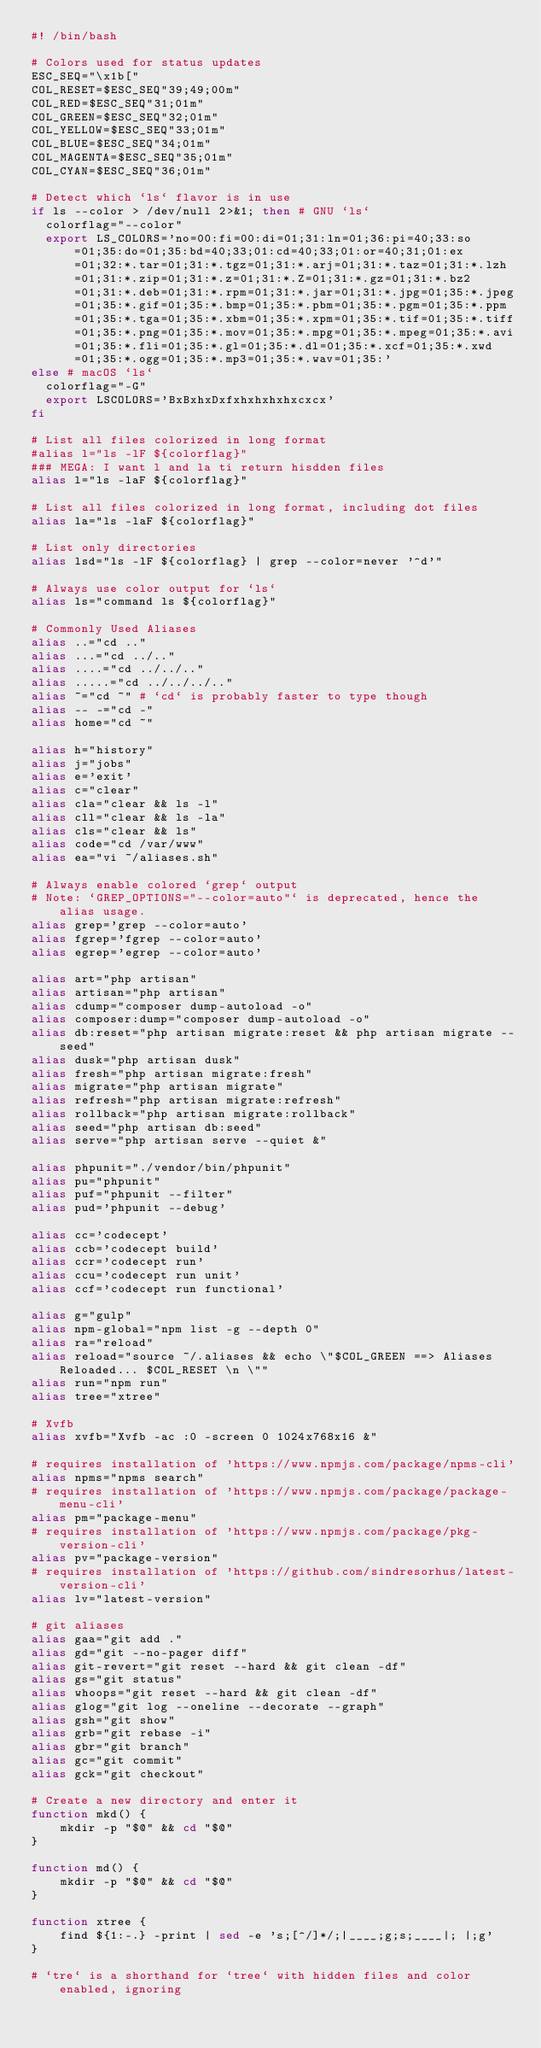<code> <loc_0><loc_0><loc_500><loc_500><_Bash_>#! /bin/bash

# Colors used for status updates
ESC_SEQ="\x1b["
COL_RESET=$ESC_SEQ"39;49;00m"
COL_RED=$ESC_SEQ"31;01m"
COL_GREEN=$ESC_SEQ"32;01m"
COL_YELLOW=$ESC_SEQ"33;01m"
COL_BLUE=$ESC_SEQ"34;01m"
COL_MAGENTA=$ESC_SEQ"35;01m"
COL_CYAN=$ESC_SEQ"36;01m"

# Detect which `ls` flavor is in use
if ls --color > /dev/null 2>&1; then # GNU `ls`
	colorflag="--color"
	export LS_COLORS='no=00:fi=00:di=01;31:ln=01;36:pi=40;33:so=01;35:do=01;35:bd=40;33;01:cd=40;33;01:or=40;31;01:ex=01;32:*.tar=01;31:*.tgz=01;31:*.arj=01;31:*.taz=01;31:*.lzh=01;31:*.zip=01;31:*.z=01;31:*.Z=01;31:*.gz=01;31:*.bz2=01;31:*.deb=01;31:*.rpm=01;31:*.jar=01;31:*.jpg=01;35:*.jpeg=01;35:*.gif=01;35:*.bmp=01;35:*.pbm=01;35:*.pgm=01;35:*.ppm=01;35:*.tga=01;35:*.xbm=01;35:*.xpm=01;35:*.tif=01;35:*.tiff=01;35:*.png=01;35:*.mov=01;35:*.mpg=01;35:*.mpeg=01;35:*.avi=01;35:*.fli=01;35:*.gl=01;35:*.dl=01;35:*.xcf=01;35:*.xwd=01;35:*.ogg=01;35:*.mp3=01;35:*.wav=01;35:'
else # macOS `ls`
	colorflag="-G"
	export LSCOLORS='BxBxhxDxfxhxhxhxhxcxcx'
fi

# List all files colorized in long format
#alias l="ls -lF ${colorflag}"
### MEGA: I want l and la ti return hisdden files
alias l="ls -laF ${colorflag}"

# List all files colorized in long format, including dot files
alias la="ls -laF ${colorflag}"

# List only directories
alias lsd="ls -lF ${colorflag} | grep --color=never '^d'"

# Always use color output for `ls`
alias ls="command ls ${colorflag}"

# Commonly Used Aliases
alias ..="cd .."
alias ...="cd ../.."
alias ....="cd ../../.."
alias .....="cd ../../../.."
alias ~="cd ~" # `cd` is probably faster to type though
alias -- -="cd -"
alias home="cd ~"

alias h="history"
alias j="jobs"
alias e='exit'
alias c="clear"
alias cla="clear && ls -l"
alias cll="clear && ls -la"
alias cls="clear && ls"
alias code="cd /var/www"
alias ea="vi ~/aliases.sh"

# Always enable colored `grep` output
# Note: `GREP_OPTIONS="--color=auto"` is deprecated, hence the alias usage.
alias grep='grep --color=auto'
alias fgrep='fgrep --color=auto'
alias egrep='egrep --color=auto'

alias art="php artisan"
alias artisan="php artisan"
alias cdump="composer dump-autoload -o"
alias composer:dump="composer dump-autoload -o"
alias db:reset="php artisan migrate:reset && php artisan migrate --seed"
alias dusk="php artisan dusk"
alias fresh="php artisan migrate:fresh"
alias migrate="php artisan migrate"
alias refresh="php artisan migrate:refresh"
alias rollback="php artisan migrate:rollback"
alias seed="php artisan db:seed"
alias serve="php artisan serve --quiet &"

alias phpunit="./vendor/bin/phpunit"
alias pu="phpunit"
alias puf="phpunit --filter"
alias pud='phpunit --debug'

alias cc='codecept'
alias ccb='codecept build'
alias ccr='codecept run'
alias ccu='codecept run unit'
alias ccf='codecept run functional'

alias g="gulp"
alias npm-global="npm list -g --depth 0"
alias ra="reload"
alias reload="source ~/.aliases && echo \"$COL_GREEN ==> Aliases Reloaded... $COL_RESET \n \""
alias run="npm run"
alias tree="xtree"

# Xvfb
alias xvfb="Xvfb -ac :0 -screen 0 1024x768x16 &"

# requires installation of 'https://www.npmjs.com/package/npms-cli'
alias npms="npms search"
# requires installation of 'https://www.npmjs.com/package/package-menu-cli'
alias pm="package-menu"
# requires installation of 'https://www.npmjs.com/package/pkg-version-cli'
alias pv="package-version"
# requires installation of 'https://github.com/sindresorhus/latest-version-cli'
alias lv="latest-version"

# git aliases
alias gaa="git add ."
alias gd="git --no-pager diff"
alias git-revert="git reset --hard && git clean -df"
alias gs="git status"
alias whoops="git reset --hard && git clean -df"
alias glog="git log --oneline --decorate --graph"
alias gsh="git show"
alias grb="git rebase -i"
alias gbr="git branch"
alias gc="git commit"
alias gck="git checkout"

# Create a new directory and enter it
function mkd() {
    mkdir -p "$@" && cd "$@"
}

function md() {
    mkdir -p "$@" && cd "$@"
}

function xtree {
    find ${1:-.} -print | sed -e 's;[^/]*/;|____;g;s;____|; |;g'
}

# `tre` is a shorthand for `tree` with hidden files and color enabled, ignoring</code> 